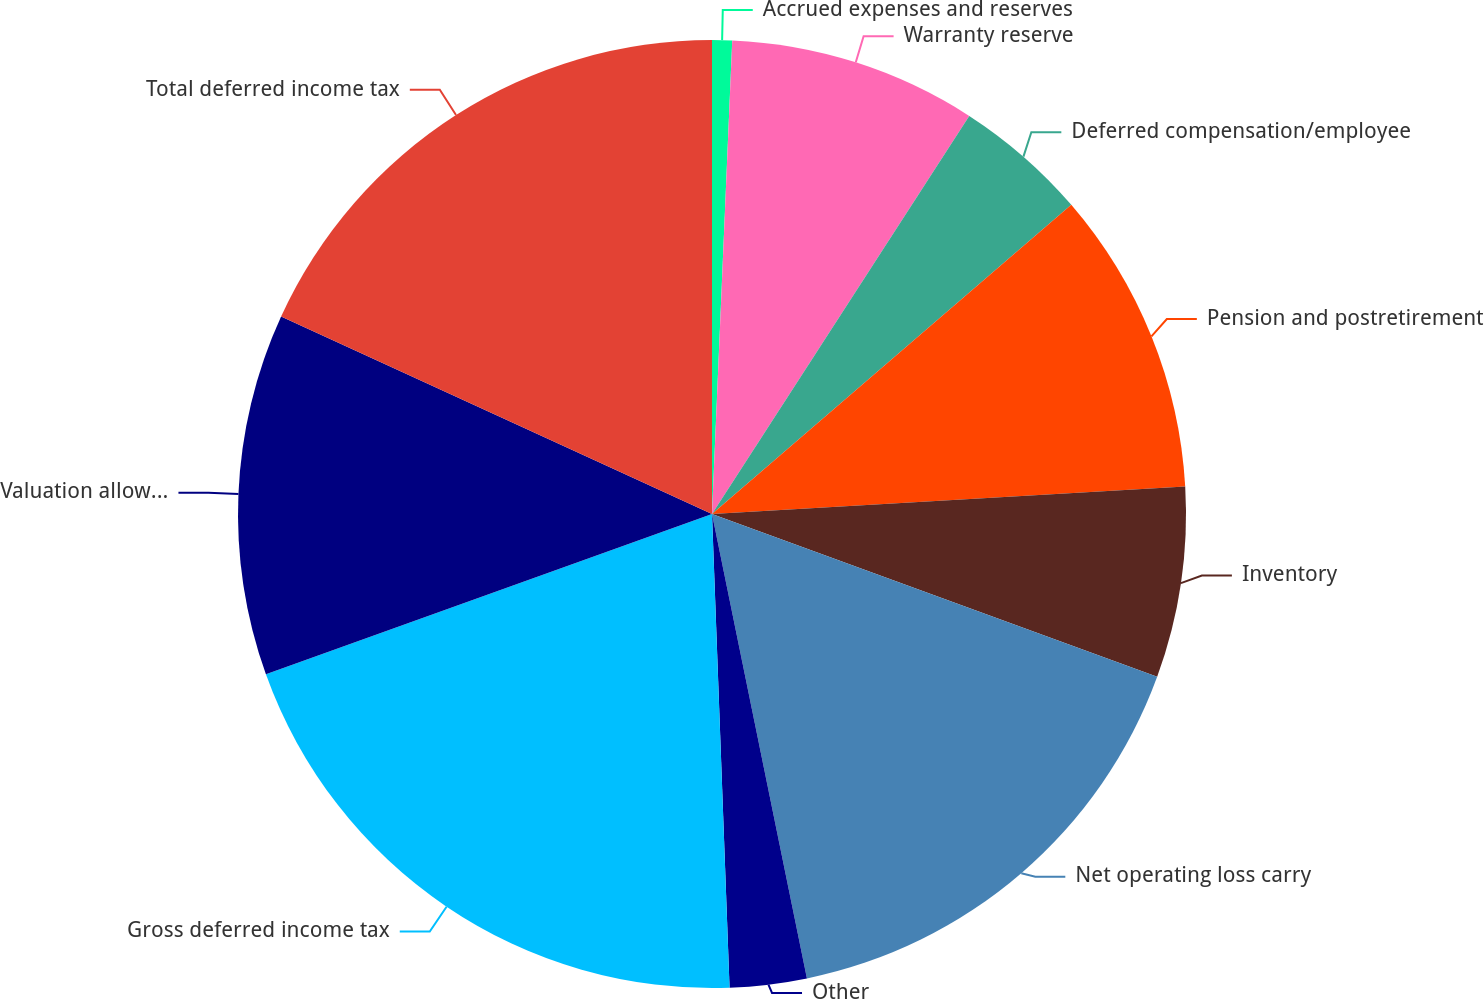Convert chart to OTSL. <chart><loc_0><loc_0><loc_500><loc_500><pie_chart><fcel>Accrued expenses and reserves<fcel>Warranty reserve<fcel>Deferred compensation/employee<fcel>Pension and postretirement<fcel>Inventory<fcel>Net operating loss carry<fcel>Other<fcel>Gross deferred income tax<fcel>Valuation allowance<fcel>Total deferred income tax<nl><fcel>0.68%<fcel>8.45%<fcel>4.56%<fcel>10.39%<fcel>6.5%<fcel>16.21%<fcel>2.62%<fcel>20.1%<fcel>12.33%<fcel>18.16%<nl></chart> 